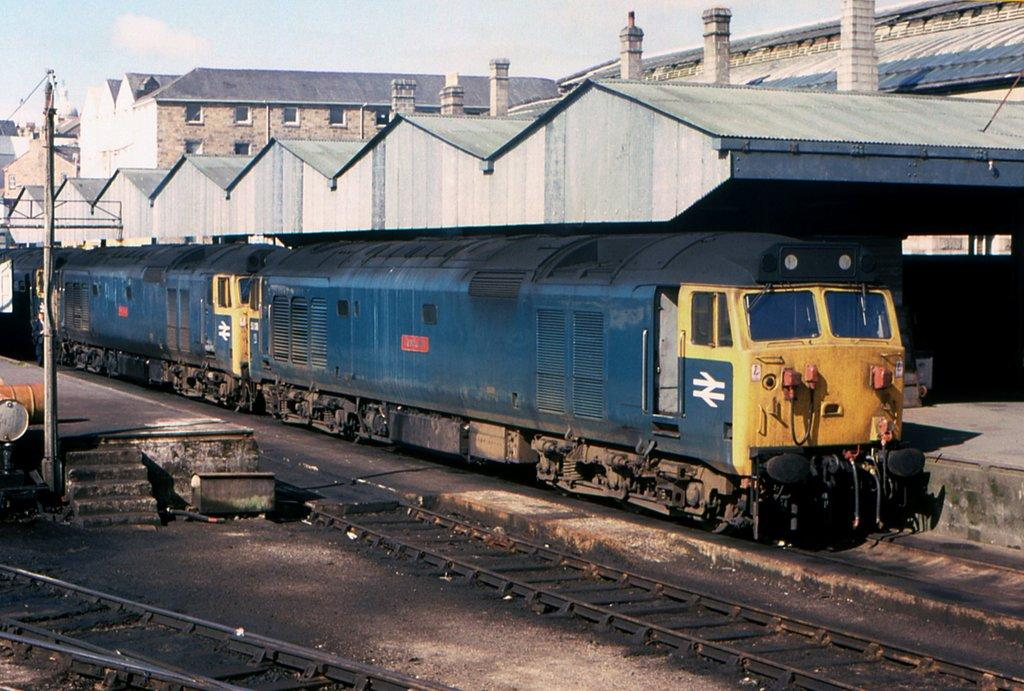What type of vehicles can be seen on the track in the image? There are trains on the track in the image. What structures are visible near the track? There are buildings visible near the track. What shape is the desire of the person in the image? There is no person present in the image, and therefore no desire to determine a shape for. 